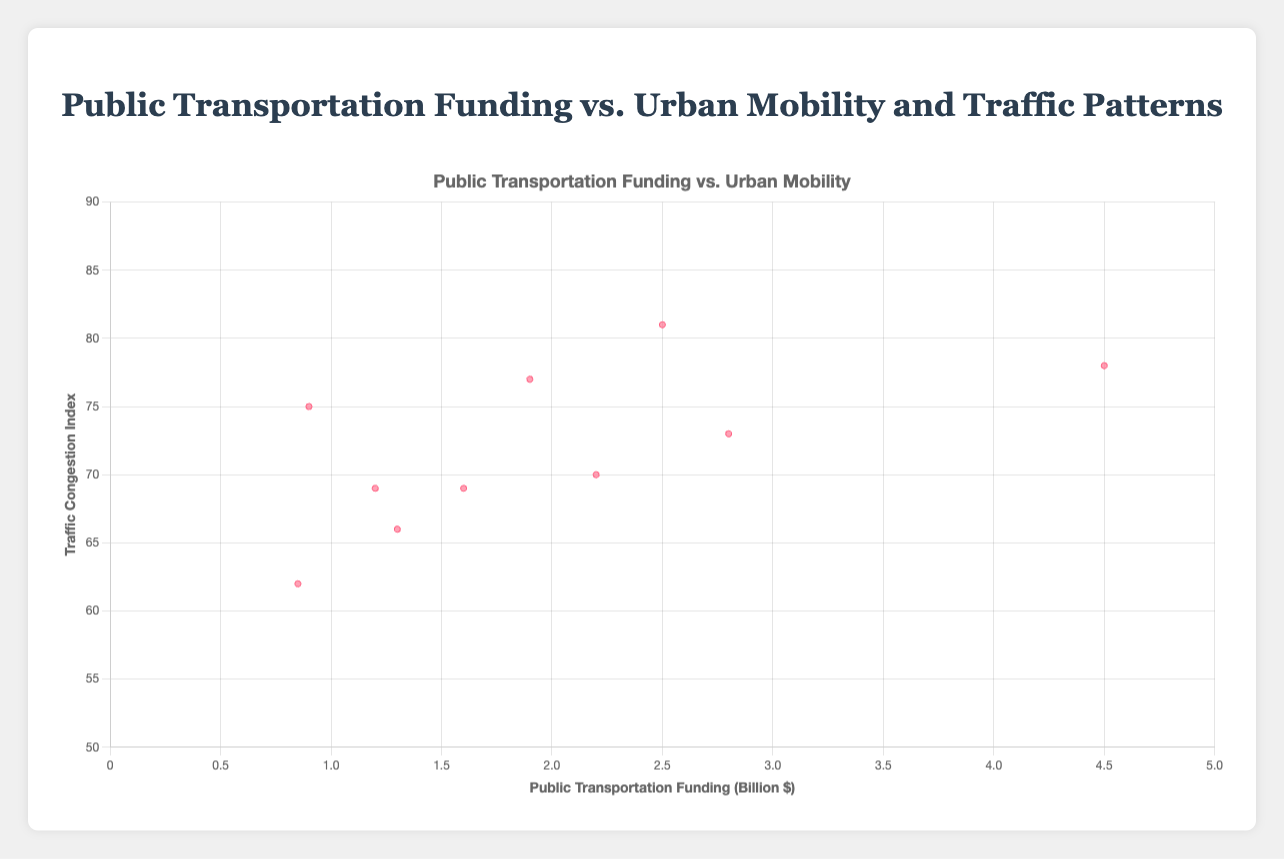What is the title of the chart? The title of the chart is displayed at the top. It reads "Public Transportation Funding vs. Urban Mobility and Traffic Patterns".
Answer: Public Transportation Funding vs. Urban Mobility and Traffic Patterns What does the X-axis represent? The X-axis represents public transportation funding in billion dollars.
Answer: public transportation funding in billion dollars Which city has the highest traffic congestion index? By looking at the highest point on the Y-axis, we see that Los Angeles has the highest traffic congestion index at 81.
Answer: Los Angeles What is the public transit usage for New York City? Hovering over the data point for New York, the tooltip shows that the public transit usage is 56%.
Answer: 56% Which city has the least funding for public transportation? By examining the leftmost point on the X-axis, we can see that Denver has the least funding at $0.85 billion.
Answer: Denver What is the average traffic congestion index for New York and Los Angeles? First, retrieve the traffic congestion indices for New York (78) and Los Angeles (81). Then, compute their average: (78 + 81) / 2 = 159 / 2 = 79.5.
Answer: 79.5 Which city has the next highest public transit usage after New York? By comparing the public transit usage percentages, Washington D.C. follows New York with a transit usage of 37%.
Answer: Washington D.C How does public transit usage correlate with traffic congestion in Los Angeles and Houston? In Los Angeles, high traffic congestion (81) pairs with lower transit usage (23%). In Houston, it's similar with high traffic congestion (75) and even lower transit usage (16%). There appears to be an inverse correlation in these cities.
Answer: inverse correlation For cities with funding between $1 billion and $3 billion, which has the highest public transit usage? Filter cities within the funding range ($1 billion to $3 billion) and check their public transit usage: Los Angeles (23%), Chicago (33%), San Francisco (36%), Washington D.C. (37%), Boston (38%). Boston has the highest public transit usage at 38%.
Answer: Boston What pattern do you observe between funding levels and traffic congestion for cities between $2 billion and $3 billion? For cities with funding levels between $2 billion and $3 billion (Los Angeles, Chicago, and San Francisco), the traffic congestion indices vary: LA (81), Chicago (73), and SF (70). Higher funding appears mildly correlated with lower congestion within this range.
Answer: mildly correlated with lower congestion 